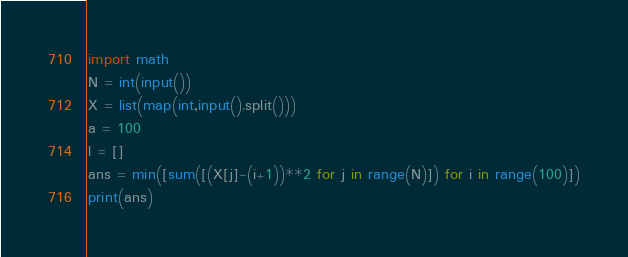Convert code to text. <code><loc_0><loc_0><loc_500><loc_500><_Python_>import math
N = int(input())
X = list(map(int,input().split()))
a = 100
l = []
ans = min([sum([(X[j]-(i+1))**2 for j in range(N)]) for i in range(100)])
print(ans)
</code> 